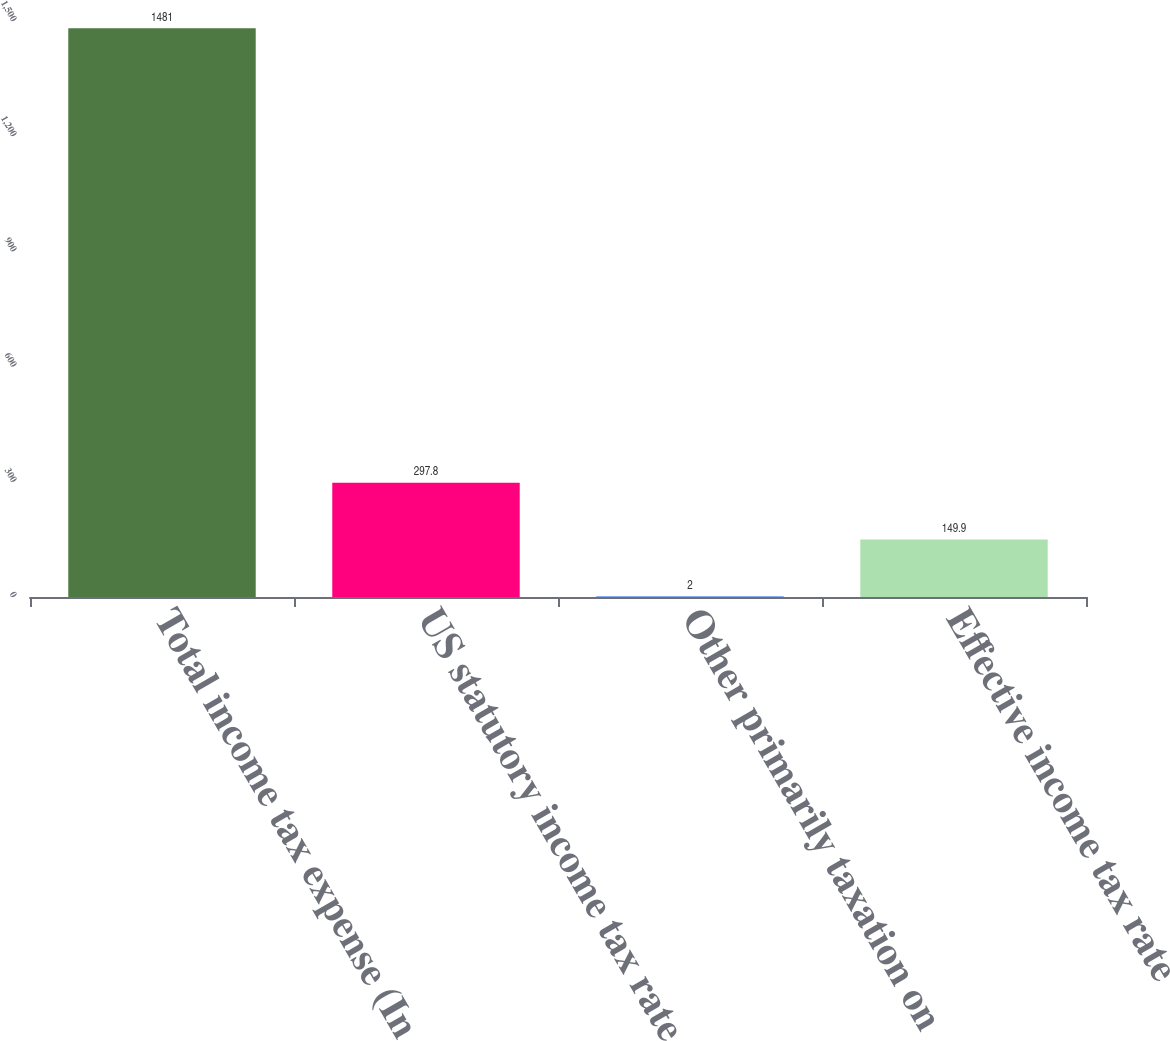Convert chart to OTSL. <chart><loc_0><loc_0><loc_500><loc_500><bar_chart><fcel>Total income tax expense (In<fcel>US statutory income tax rate<fcel>Other primarily taxation on<fcel>Effective income tax rate<nl><fcel>1481<fcel>297.8<fcel>2<fcel>149.9<nl></chart> 